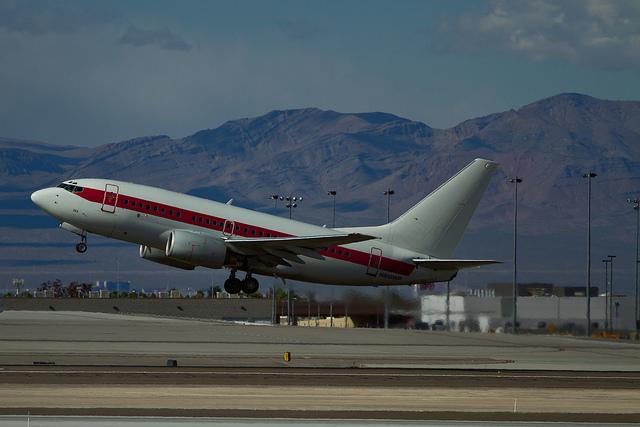What color is the planes tail?
Quick response, please. White. How many wheels are on the ground?
Quick response, please. 0. What color is the tail of the plane?
Be succinct. White. Is this a commercial or personal airplane?
Short answer required. Commercial. Is the plane in motion?
Keep it brief. Yes. Is this plan taking off?
Concise answer only. Yes. Are there clouds in the sky?
Short answer required. Yes. 